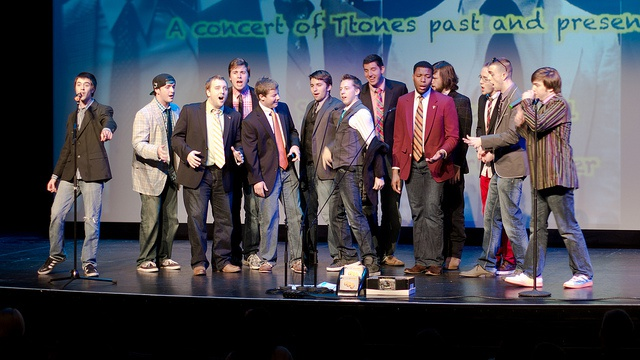Describe the objects in this image and their specific colors. I can see people in black, gray, and brown tones, people in black, gray, and ivory tones, people in black, darkgray, and gray tones, people in black, brown, and maroon tones, and people in black, gray, and maroon tones in this image. 